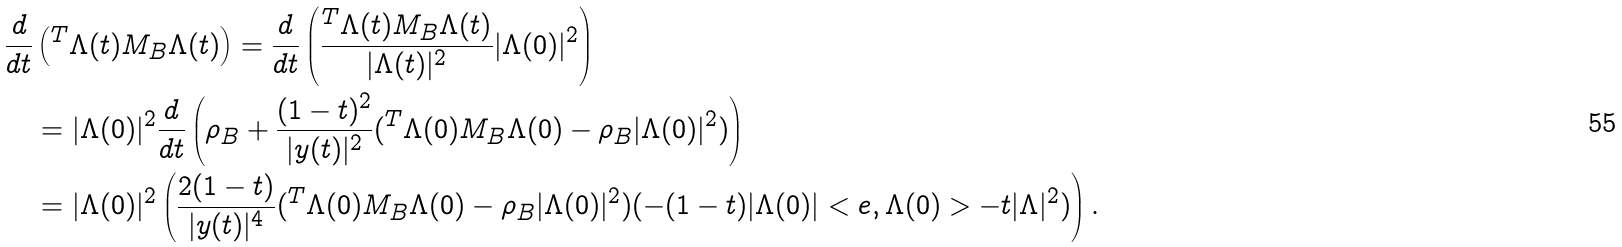<formula> <loc_0><loc_0><loc_500><loc_500>\frac { d } { d t } & \left ( ^ { T } \Lambda ( t ) M _ { B } \Lambda ( t ) \right ) = \frac { d } { d t } \left ( \frac { ^ { T } \Lambda ( t ) M _ { B } \Lambda ( t ) } { | \Lambda ( t ) | ^ { 2 } } | \Lambda ( 0 ) | ^ { 2 } \right ) \\ & = | \Lambda ( 0 ) | ^ { 2 } \frac { d } { d t } \left ( \rho _ { B } + \frac { ( 1 - t ) ^ { 2 } } { | y ( t ) | ^ { 2 } } ( ^ { T } \Lambda ( 0 ) M _ { B } \Lambda ( 0 ) - \rho _ { B } | \Lambda ( 0 ) | ^ { 2 } ) \right ) \\ & = | \Lambda ( 0 ) | ^ { 2 } \left ( \frac { 2 ( 1 - t ) } { | y ( t ) | ^ { 4 } } ( ^ { T } \Lambda ( 0 ) M _ { B } \Lambda ( 0 ) - \rho _ { B } | \Lambda ( 0 ) | ^ { 2 } ) ( - ( 1 - t ) | \Lambda ( 0 ) | < e , \Lambda ( 0 ) > - t | \Lambda | ^ { 2 } ) \right ) .</formula> 